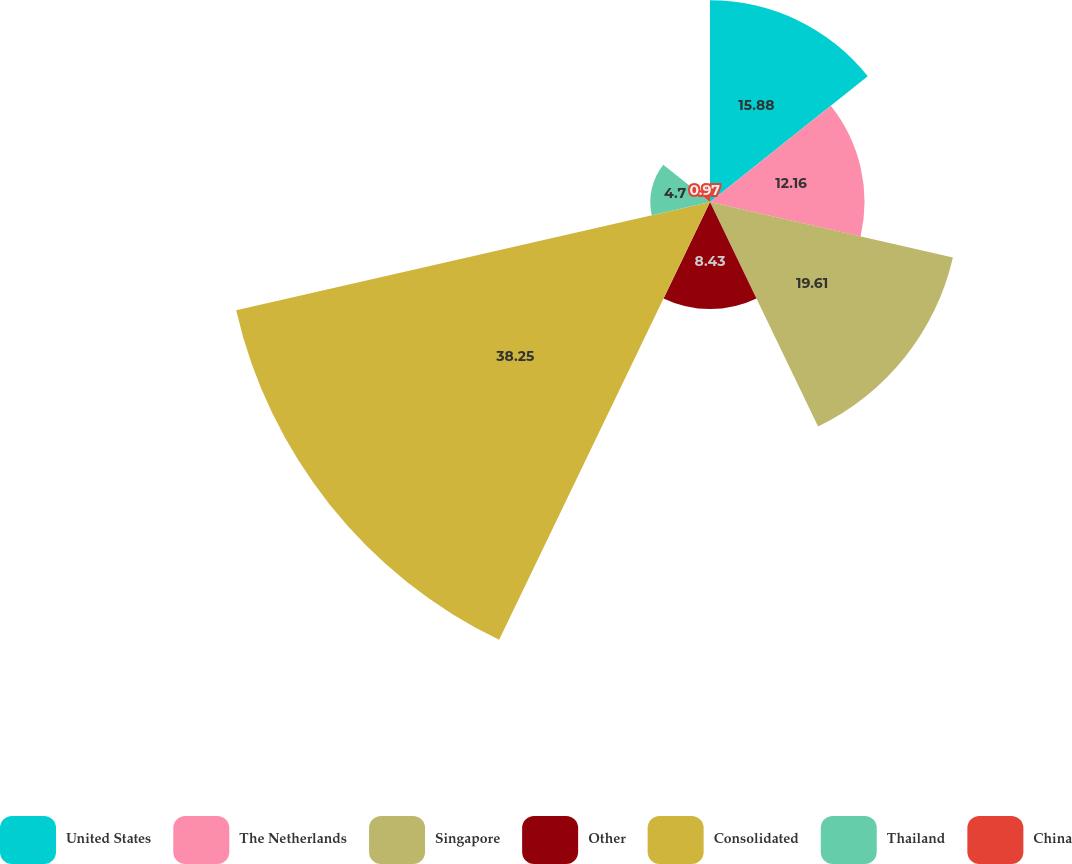<chart> <loc_0><loc_0><loc_500><loc_500><pie_chart><fcel>United States<fcel>The Netherlands<fcel>Singapore<fcel>Other<fcel>Consolidated<fcel>Thailand<fcel>China<nl><fcel>15.88%<fcel>12.16%<fcel>19.61%<fcel>8.43%<fcel>38.25%<fcel>4.7%<fcel>0.97%<nl></chart> 